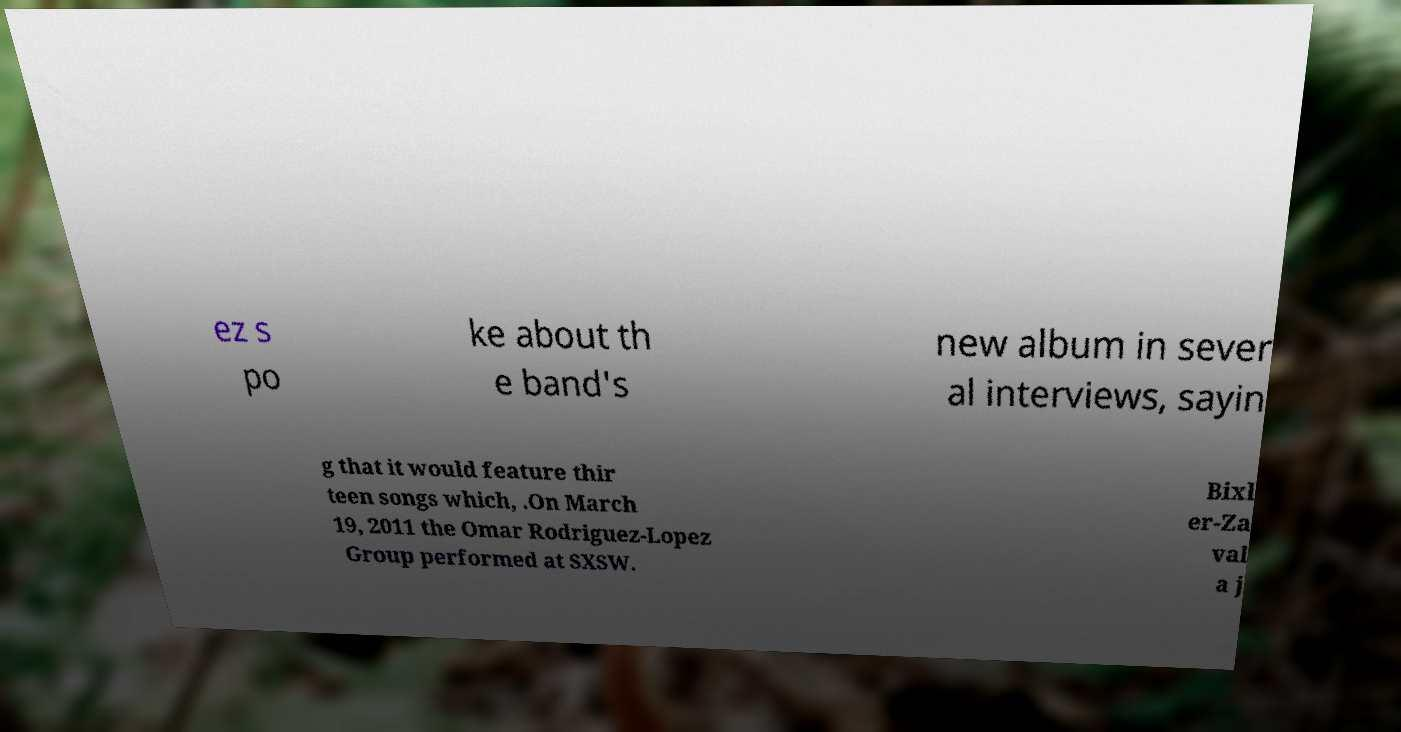Could you extract and type out the text from this image? ez s po ke about th e band's new album in sever al interviews, sayin g that it would feature thir teen songs which, .On March 19, 2011 the Omar Rodriguez-Lopez Group performed at SXSW. Bixl er-Za val a j 